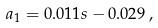<formula> <loc_0><loc_0><loc_500><loc_500>a _ { 1 } = 0 . 0 1 1 s - 0 . 0 2 9 \, ,</formula> 